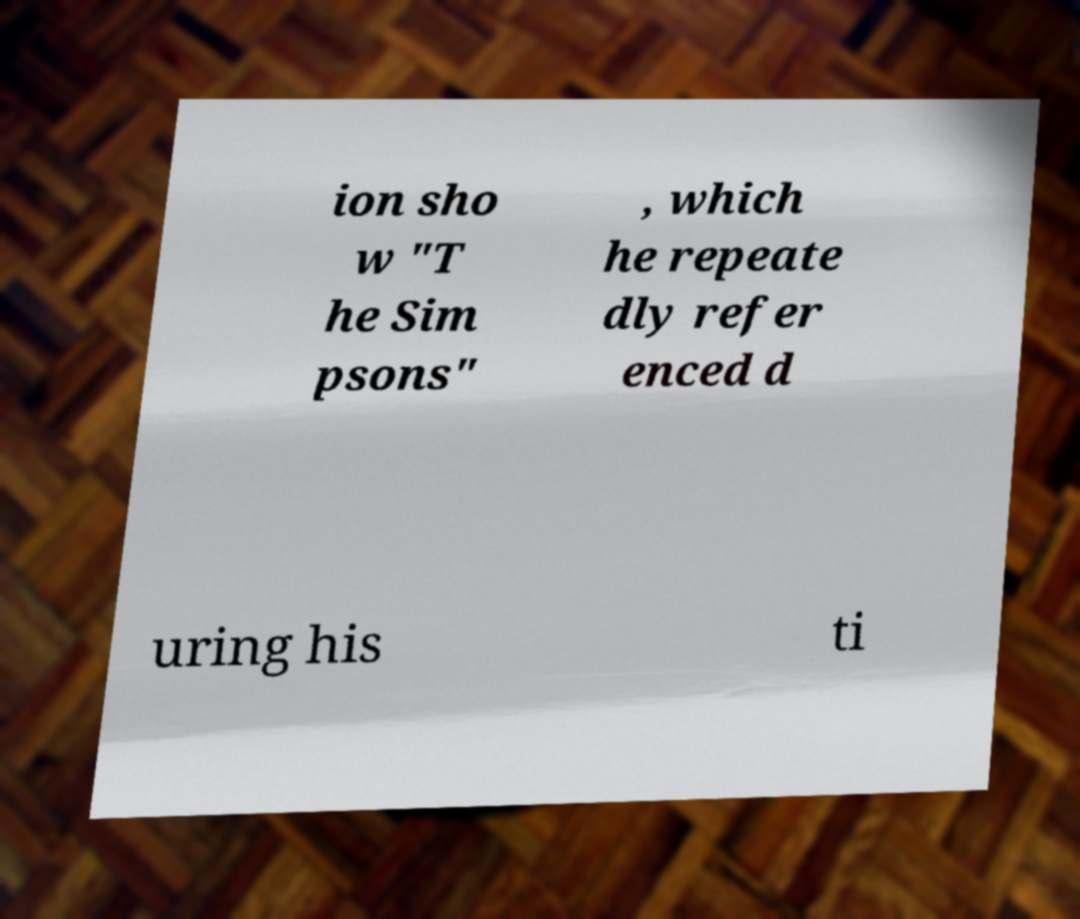What messages or text are displayed in this image? I need them in a readable, typed format. ion sho w "T he Sim psons" , which he repeate dly refer enced d uring his ti 